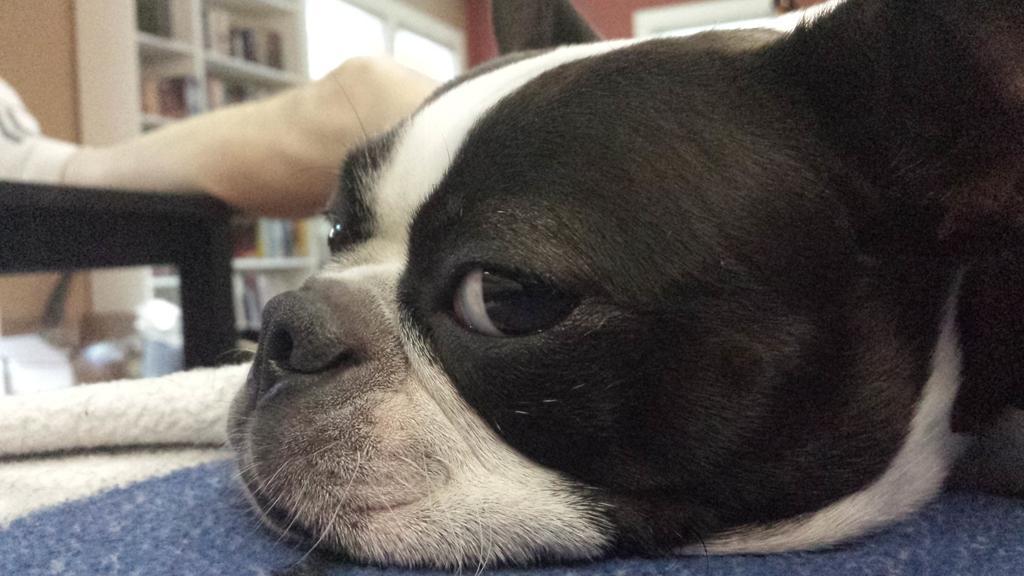Please provide a concise description of this image. In this image there is a dog laying on the carpet, a person leg on the table, objects in the shelves, wall. 